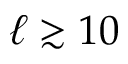Convert formula to latex. <formula><loc_0><loc_0><loc_500><loc_500>\ell \gtrsim 1 0</formula> 